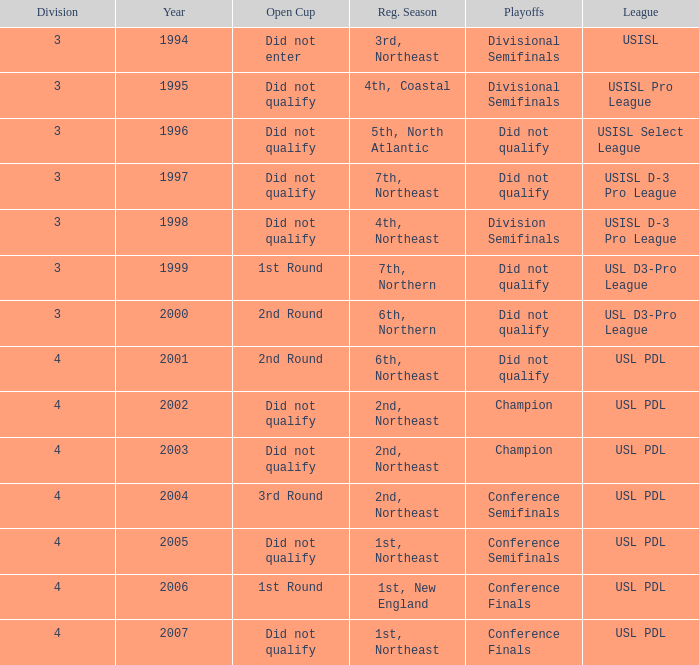Name the league for 2003 USL PDL. 